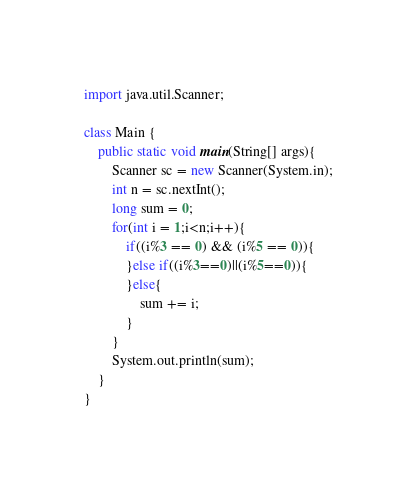Convert code to text. <code><loc_0><loc_0><loc_500><loc_500><_Java_>import java.util.Scanner;

class Main {
	public static void main(String[] args){
		Scanner sc = new Scanner(System.in);
		int n = sc.nextInt();
		long sum = 0;
		for(int i = 1;i<n;i++){
			if((i%3 == 0) && (i%5 == 0)){
			}else if((i%3==0)||(i%5==0)){
			}else{
				sum += i;
			}
		}
		System.out.println(sum);
	}
}
</code> 